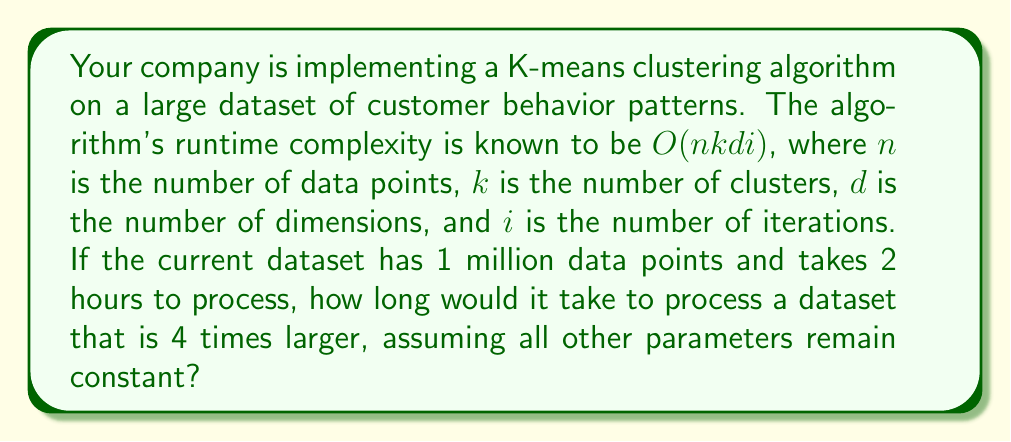Teach me how to tackle this problem. Let's approach this step-by-step:

1) The runtime complexity of the K-means algorithm is $O(nkdi)$. This means the runtime is directly proportional to $n$, the number of data points.

2) Let's define variables:
   $t_1$ = time for original dataset
   $n_1$ = size of original dataset
   $t_2$ = time for new dataset
   $n_2$ = size of new dataset

3) We know:
   $t_1 = 2$ hours
   $n_1 = 1$ million
   $n_2 = 4n_1 = 4$ million

4) Since the runtime is directly proportional to $n$, we can set up the following proportion:

   $$\frac{t_1}{n_1} = \frac{t_2}{n_2}$$

5) Substituting the known values:

   $$\frac{2}{1,000,000} = \frac{t_2}{4,000,000}$$

6) Cross-multiplying:

   $$2 * 4,000,000 = 1,000,000 * t_2$$

7) Solving for $t_2$:

   $$t_2 = \frac{2 * 4,000,000}{1,000,000} = 8$$

Therefore, it would take 8 hours to process the larger dataset.
Answer: 8 hours 